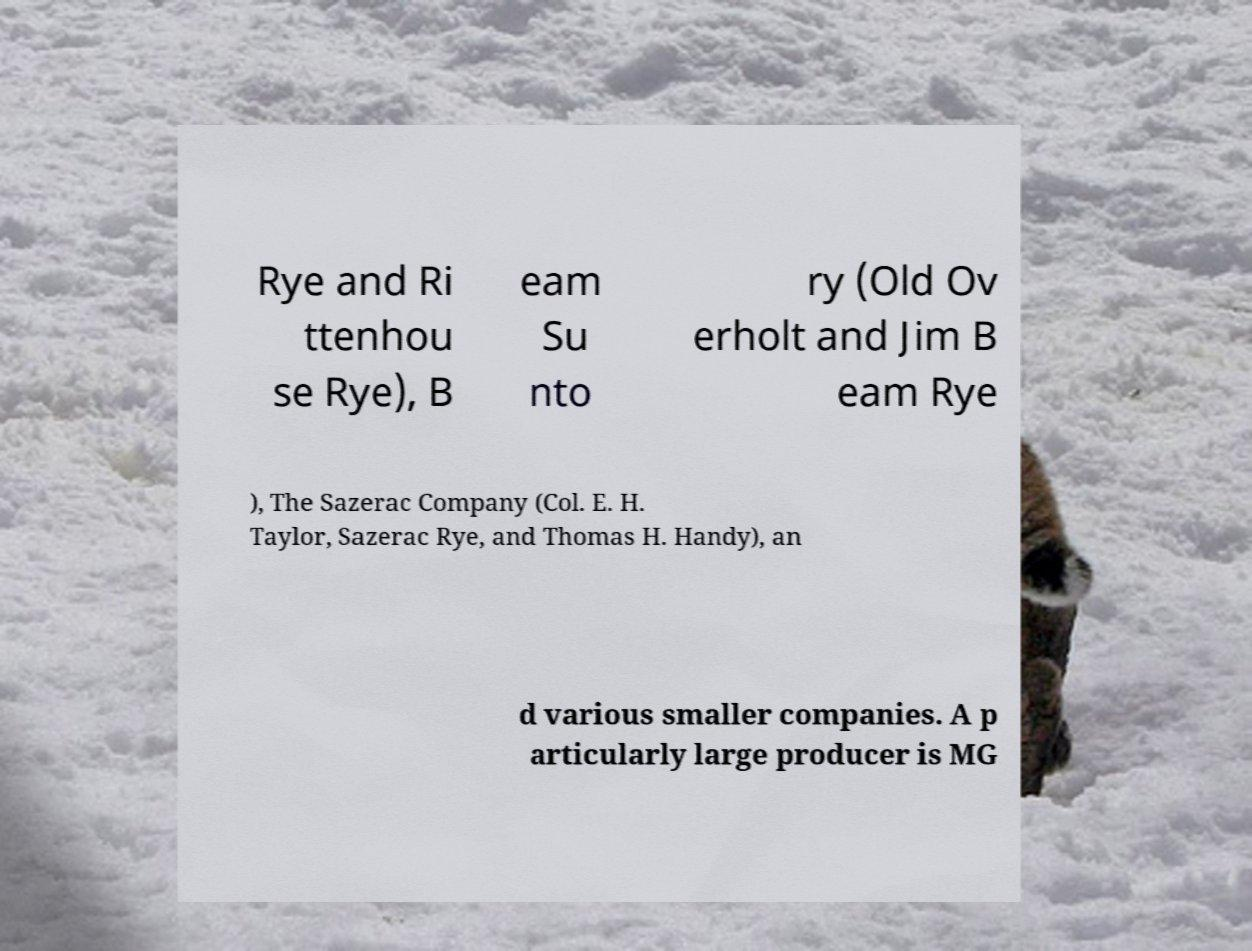Can you read and provide the text displayed in the image?This photo seems to have some interesting text. Can you extract and type it out for me? Rye and Ri ttenhou se Rye), B eam Su nto ry (Old Ov erholt and Jim B eam Rye ), The Sazerac Company (Col. E. H. Taylor, Sazerac Rye, and Thomas H. Handy), an d various smaller companies. A p articularly large producer is MG 